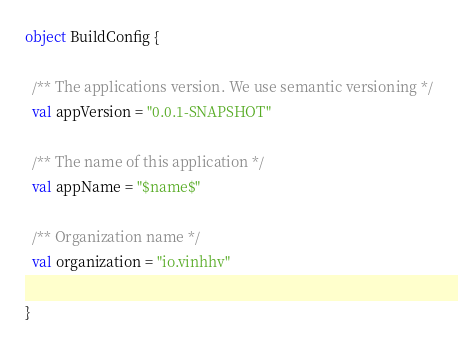<code> <loc_0><loc_0><loc_500><loc_500><_Scala_>object BuildConfig {

  /** The applications version. We use semantic versioning */
  val appVersion = "0.0.1-SNAPSHOT"

  /** The name of this application */
  val appName = "$name$"

  /** Organization name */
  val organization = "io.vinhhv"

}
</code> 